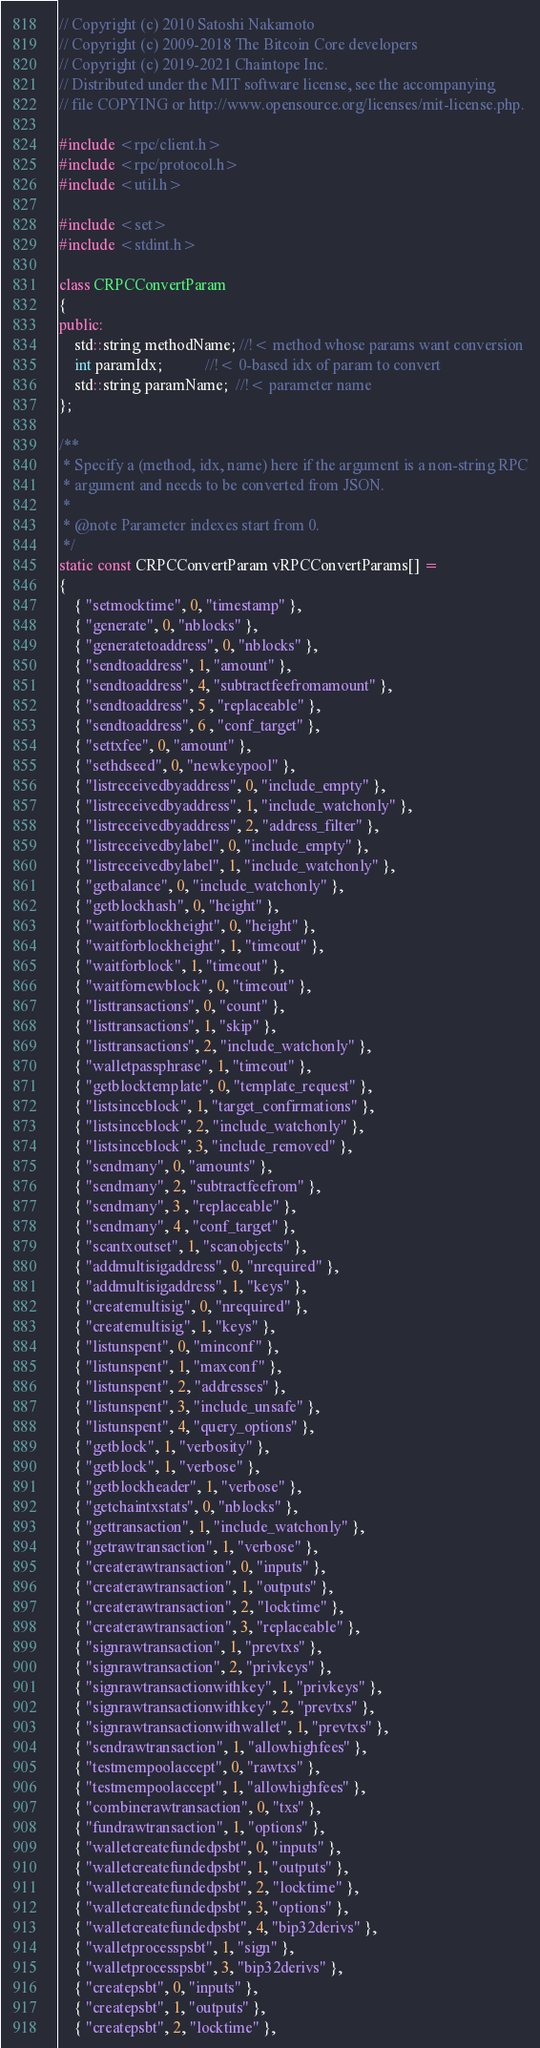<code> <loc_0><loc_0><loc_500><loc_500><_C++_>// Copyright (c) 2010 Satoshi Nakamoto
// Copyright (c) 2009-2018 The Bitcoin Core developers
// Copyright (c) 2019-2021 Chaintope Inc.
// Distributed under the MIT software license, see the accompanying
// file COPYING or http://www.opensource.org/licenses/mit-license.php.

#include <rpc/client.h>
#include <rpc/protocol.h>
#include <util.h>

#include <set>
#include <stdint.h>

class CRPCConvertParam
{
public:
    std::string methodName; //!< method whose params want conversion
    int paramIdx;           //!< 0-based idx of param to convert
    std::string paramName;  //!< parameter name
};

/**
 * Specify a (method, idx, name) here if the argument is a non-string RPC
 * argument and needs to be converted from JSON.
 *
 * @note Parameter indexes start from 0.
 */
static const CRPCConvertParam vRPCConvertParams[] =
{
    { "setmocktime", 0, "timestamp" },
    { "generate", 0, "nblocks" },
    { "generatetoaddress", 0, "nblocks" },
    { "sendtoaddress", 1, "amount" },
    { "sendtoaddress", 4, "subtractfeefromamount" },
    { "sendtoaddress", 5 , "replaceable" },
    { "sendtoaddress", 6 , "conf_target" },
    { "settxfee", 0, "amount" },
    { "sethdseed", 0, "newkeypool" },
    { "listreceivedbyaddress", 0, "include_empty" },
    { "listreceivedbyaddress", 1, "include_watchonly" },
    { "listreceivedbyaddress", 2, "address_filter" },
    { "listreceivedbylabel", 0, "include_empty" },
    { "listreceivedbylabel", 1, "include_watchonly" },
    { "getbalance", 0, "include_watchonly" },
    { "getblockhash", 0, "height" },
    { "waitforblockheight", 0, "height" },
    { "waitforblockheight", 1, "timeout" },
    { "waitforblock", 1, "timeout" },
    { "waitfornewblock", 0, "timeout" },
    { "listtransactions", 0, "count" },
    { "listtransactions", 1, "skip" },
    { "listtransactions", 2, "include_watchonly" },
    { "walletpassphrase", 1, "timeout" },
    { "getblocktemplate", 0, "template_request" },
    { "listsinceblock", 1, "target_confirmations" },
    { "listsinceblock", 2, "include_watchonly" },
    { "listsinceblock", 3, "include_removed" },
    { "sendmany", 0, "amounts" },
    { "sendmany", 2, "subtractfeefrom" },
    { "sendmany", 3 , "replaceable" },
    { "sendmany", 4 , "conf_target" },
    { "scantxoutset", 1, "scanobjects" },
    { "addmultisigaddress", 0, "nrequired" },
    { "addmultisigaddress", 1, "keys" },
    { "createmultisig", 0, "nrequired" },
    { "createmultisig", 1, "keys" },
    { "listunspent", 0, "minconf" },
    { "listunspent", 1, "maxconf" },
    { "listunspent", 2, "addresses" },
    { "listunspent", 3, "include_unsafe" },
    { "listunspent", 4, "query_options" },
    { "getblock", 1, "verbosity" },
    { "getblock", 1, "verbose" },
    { "getblockheader", 1, "verbose" },
    { "getchaintxstats", 0, "nblocks" },
    { "gettransaction", 1, "include_watchonly" },
    { "getrawtransaction", 1, "verbose" },
    { "createrawtransaction", 0, "inputs" },
    { "createrawtransaction", 1, "outputs" },
    { "createrawtransaction", 2, "locktime" },
    { "createrawtransaction", 3, "replaceable" },
    { "signrawtransaction", 1, "prevtxs" },
    { "signrawtransaction", 2, "privkeys" },
    { "signrawtransactionwithkey", 1, "privkeys" },
    { "signrawtransactionwithkey", 2, "prevtxs" },
    { "signrawtransactionwithwallet", 1, "prevtxs" },
    { "sendrawtransaction", 1, "allowhighfees" },
    { "testmempoolaccept", 0, "rawtxs" },
    { "testmempoolaccept", 1, "allowhighfees" },
    { "combinerawtransaction", 0, "txs" },
    { "fundrawtransaction", 1, "options" },
    { "walletcreatefundedpsbt", 0, "inputs" },
    { "walletcreatefundedpsbt", 1, "outputs" },
    { "walletcreatefundedpsbt", 2, "locktime" },
    { "walletcreatefundedpsbt", 3, "options" },
    { "walletcreatefundedpsbt", 4, "bip32derivs" },
    { "walletprocesspsbt", 1, "sign" },
    { "walletprocesspsbt", 3, "bip32derivs" },
    { "createpsbt", 0, "inputs" },
    { "createpsbt", 1, "outputs" },
    { "createpsbt", 2, "locktime" },</code> 